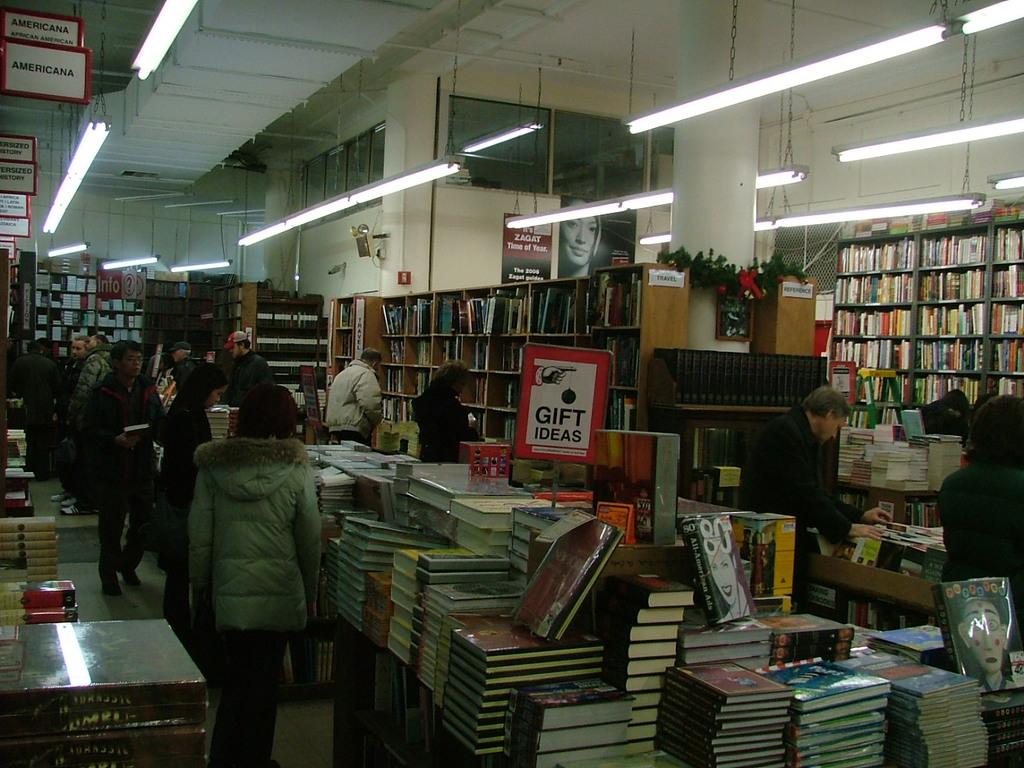What selection of books is on the table in front?
Give a very brief answer. Gift ideas. Is that a bookstore?
Give a very brief answer. Yes. 